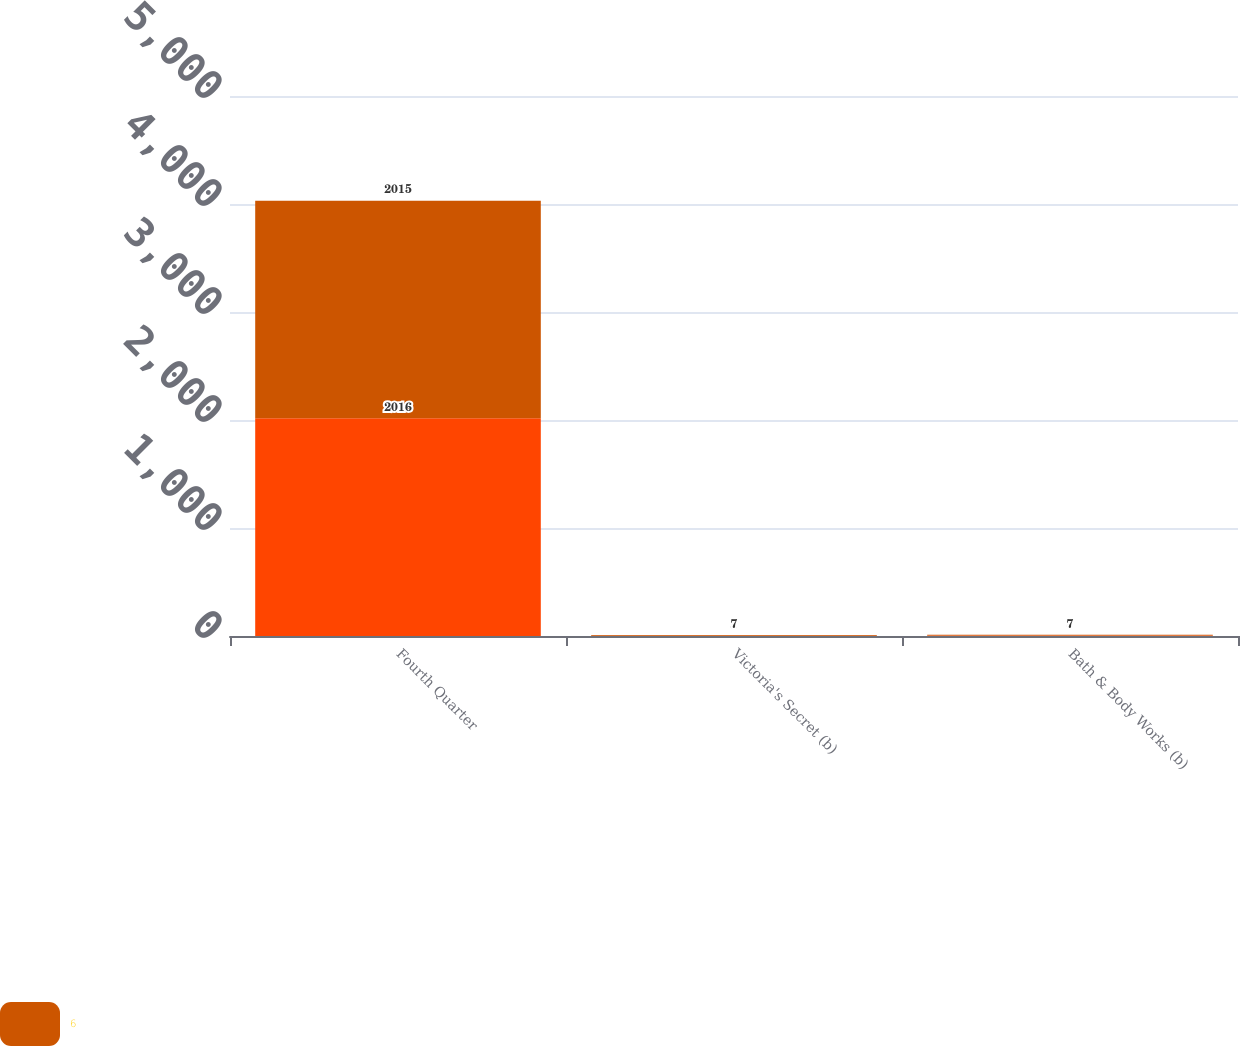Convert chart. <chart><loc_0><loc_0><loc_500><loc_500><stacked_bar_chart><ecel><fcel>Fourth Quarter<fcel>Victoria's Secret (b)<fcel>Bath & Body Works (b)<nl><fcel>nan<fcel>2016<fcel>3<fcel>5<nl><fcel>6<fcel>2015<fcel>7<fcel>7<nl></chart> 